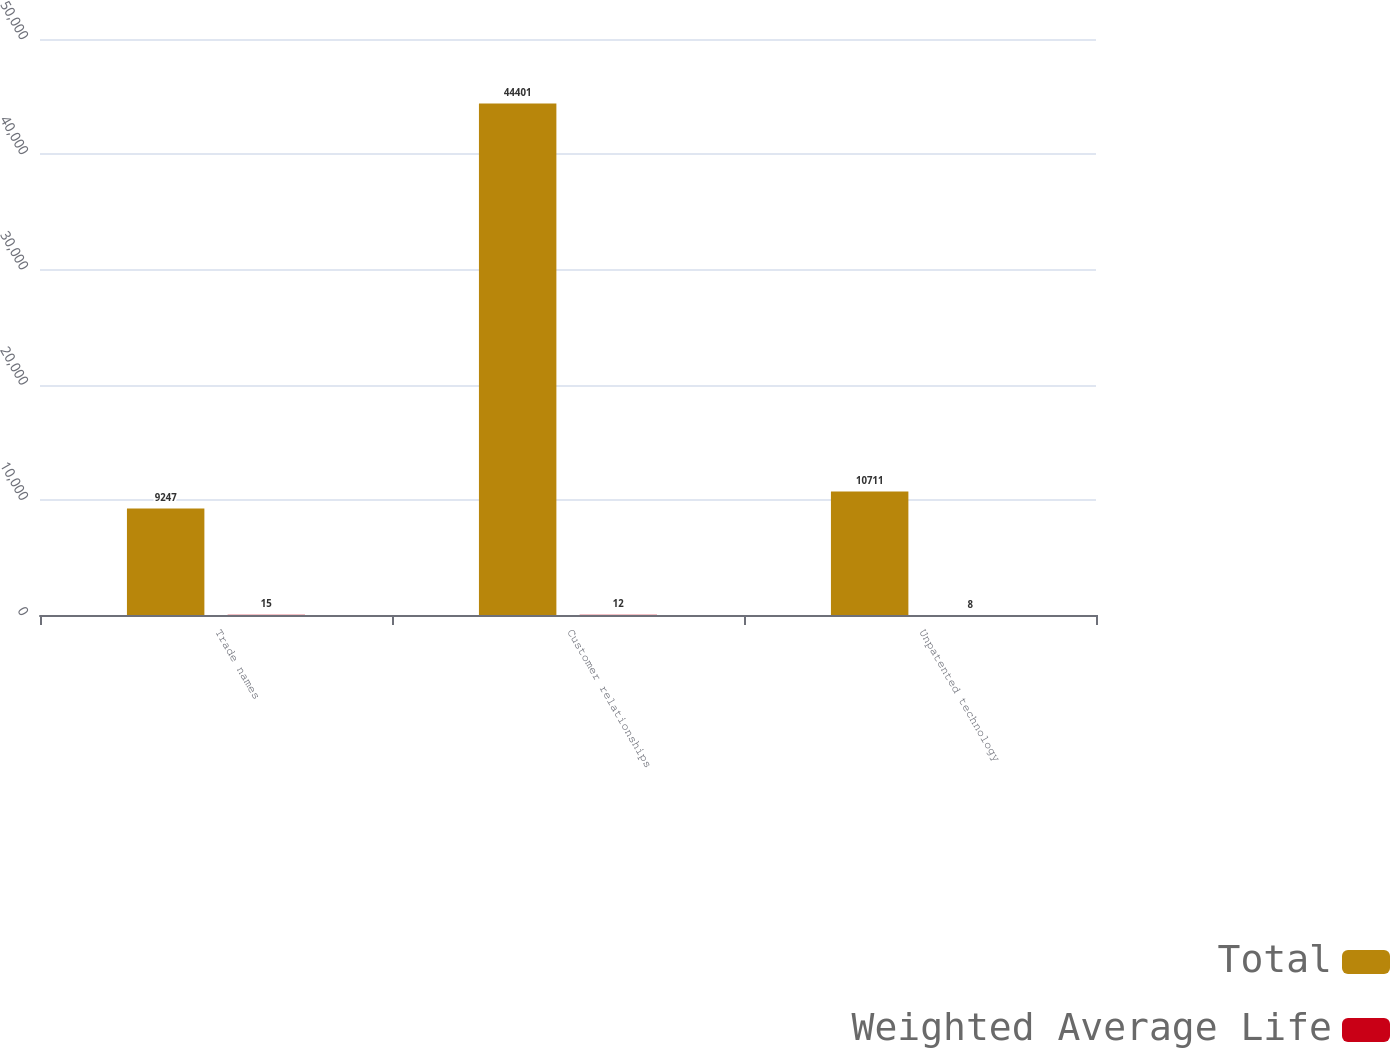Convert chart. <chart><loc_0><loc_0><loc_500><loc_500><stacked_bar_chart><ecel><fcel>Trade names<fcel>Customer relationships<fcel>Unpatented technology<nl><fcel>Total<fcel>9247<fcel>44401<fcel>10711<nl><fcel>Weighted Average Life<fcel>15<fcel>12<fcel>8<nl></chart> 